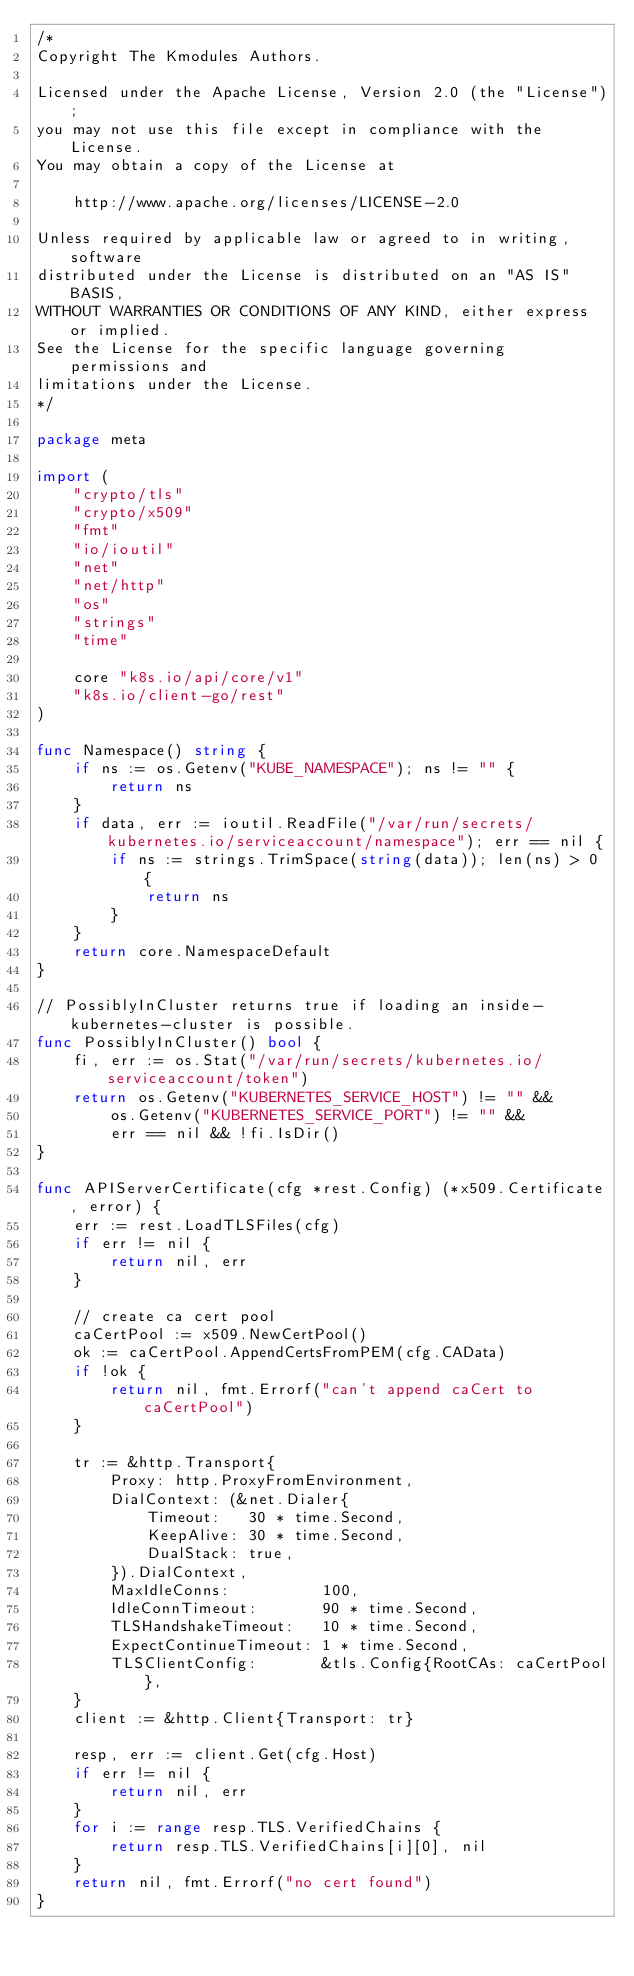Convert code to text. <code><loc_0><loc_0><loc_500><loc_500><_Go_>/*
Copyright The Kmodules Authors.

Licensed under the Apache License, Version 2.0 (the "License");
you may not use this file except in compliance with the License.
You may obtain a copy of the License at

    http://www.apache.org/licenses/LICENSE-2.0

Unless required by applicable law or agreed to in writing, software
distributed under the License is distributed on an "AS IS" BASIS,
WITHOUT WARRANTIES OR CONDITIONS OF ANY KIND, either express or implied.
See the License for the specific language governing permissions and
limitations under the License.
*/

package meta

import (
	"crypto/tls"
	"crypto/x509"
	"fmt"
	"io/ioutil"
	"net"
	"net/http"
	"os"
	"strings"
	"time"

	core "k8s.io/api/core/v1"
	"k8s.io/client-go/rest"
)

func Namespace() string {
	if ns := os.Getenv("KUBE_NAMESPACE"); ns != "" {
		return ns
	}
	if data, err := ioutil.ReadFile("/var/run/secrets/kubernetes.io/serviceaccount/namespace"); err == nil {
		if ns := strings.TrimSpace(string(data)); len(ns) > 0 {
			return ns
		}
	}
	return core.NamespaceDefault
}

// PossiblyInCluster returns true if loading an inside-kubernetes-cluster is possible.
func PossiblyInCluster() bool {
	fi, err := os.Stat("/var/run/secrets/kubernetes.io/serviceaccount/token")
	return os.Getenv("KUBERNETES_SERVICE_HOST") != "" &&
		os.Getenv("KUBERNETES_SERVICE_PORT") != "" &&
		err == nil && !fi.IsDir()
}

func APIServerCertificate(cfg *rest.Config) (*x509.Certificate, error) {
	err := rest.LoadTLSFiles(cfg)
	if err != nil {
		return nil, err
	}

	// create ca cert pool
	caCertPool := x509.NewCertPool()
	ok := caCertPool.AppendCertsFromPEM(cfg.CAData)
	if !ok {
		return nil, fmt.Errorf("can't append caCert to caCertPool")
	}

	tr := &http.Transport{
		Proxy: http.ProxyFromEnvironment,
		DialContext: (&net.Dialer{
			Timeout:   30 * time.Second,
			KeepAlive: 30 * time.Second,
			DualStack: true,
		}).DialContext,
		MaxIdleConns:          100,
		IdleConnTimeout:       90 * time.Second,
		TLSHandshakeTimeout:   10 * time.Second,
		ExpectContinueTimeout: 1 * time.Second,
		TLSClientConfig:       &tls.Config{RootCAs: caCertPool},
	}
	client := &http.Client{Transport: tr}

	resp, err := client.Get(cfg.Host)
	if err != nil {
		return nil, err
	}
	for i := range resp.TLS.VerifiedChains {
		return resp.TLS.VerifiedChains[i][0], nil
	}
	return nil, fmt.Errorf("no cert found")
}
</code> 